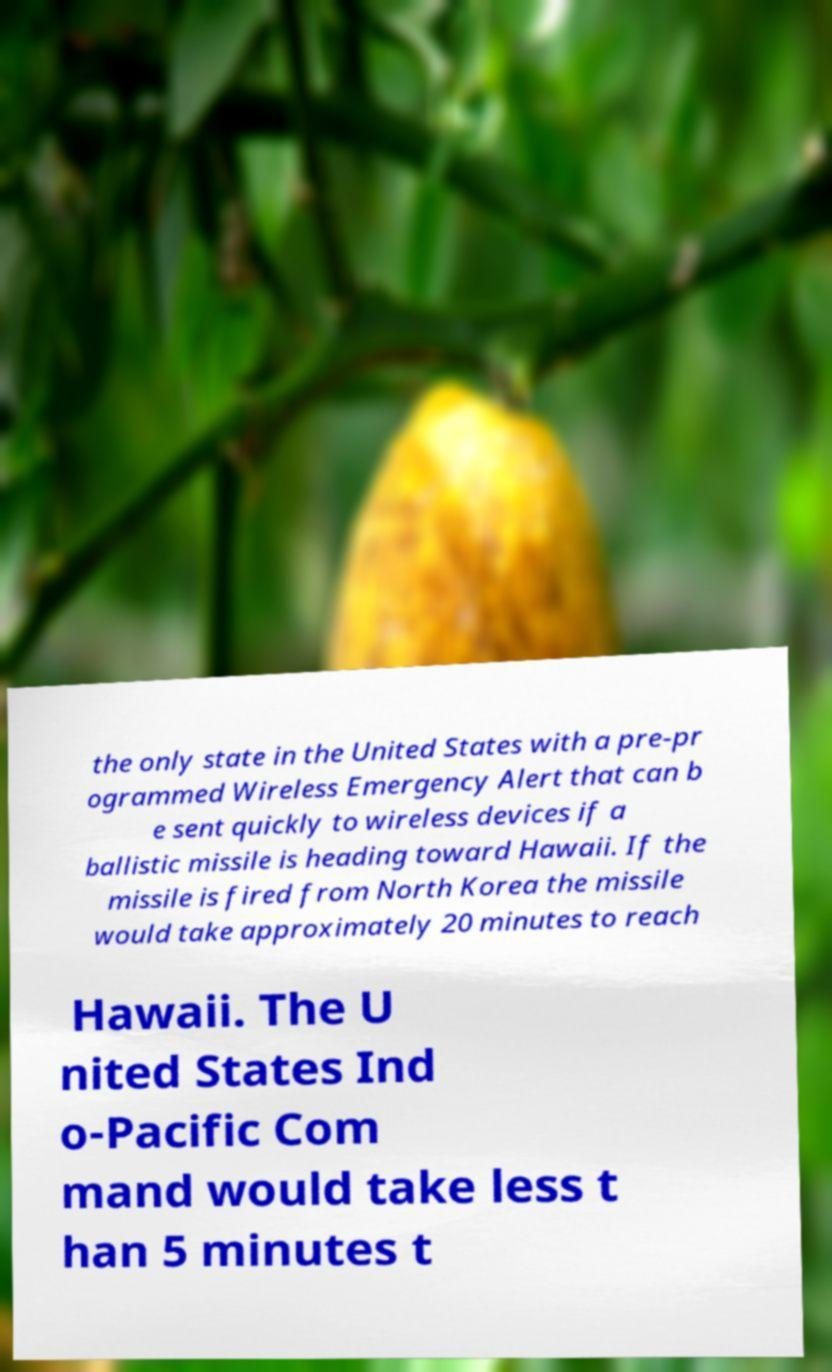There's text embedded in this image that I need extracted. Can you transcribe it verbatim? the only state in the United States with a pre-pr ogrammed Wireless Emergency Alert that can b e sent quickly to wireless devices if a ballistic missile is heading toward Hawaii. If the missile is fired from North Korea the missile would take approximately 20 minutes to reach Hawaii. The U nited States Ind o-Pacific Com mand would take less t han 5 minutes t 